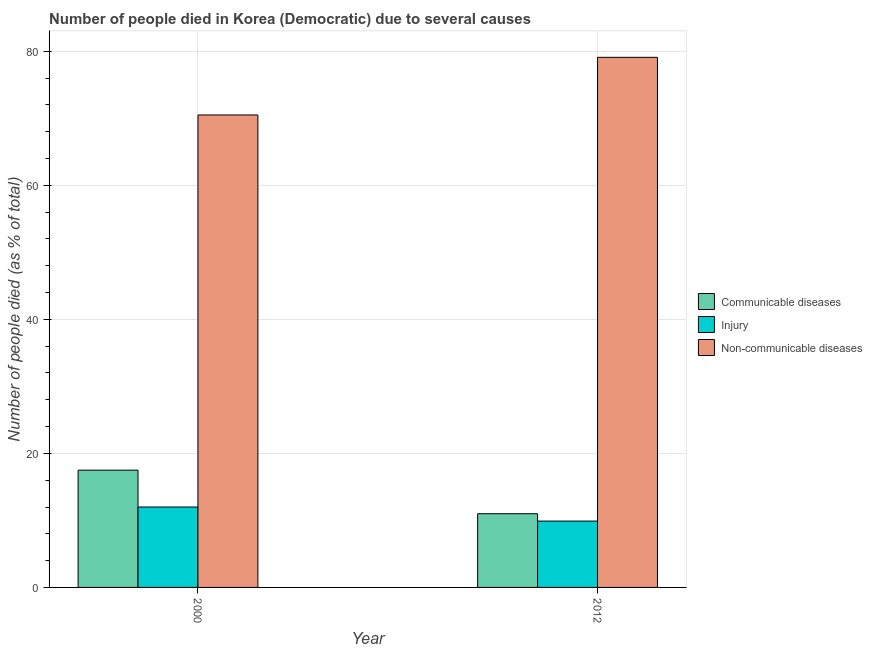How many different coloured bars are there?
Make the answer very short. 3. How many groups of bars are there?
Provide a succinct answer. 2. In how many cases, is the number of bars for a given year not equal to the number of legend labels?
Offer a very short reply. 0. What is the total number of people who died of communicable diseases in the graph?
Ensure brevity in your answer.  28.5. What is the difference between the number of people who dies of non-communicable diseases in 2000 and that in 2012?
Offer a terse response. -8.6. What is the difference between the number of people who died of communicable diseases in 2000 and the number of people who died of injury in 2012?
Provide a short and direct response. 6.5. What is the average number of people who died of communicable diseases per year?
Your response must be concise. 14.25. In how many years, is the number of people who died of communicable diseases greater than 56 %?
Provide a short and direct response. 0. What is the ratio of the number of people who died of communicable diseases in 2000 to that in 2012?
Ensure brevity in your answer.  1.59. In how many years, is the number of people who died of communicable diseases greater than the average number of people who died of communicable diseases taken over all years?
Make the answer very short. 1. What does the 1st bar from the left in 2012 represents?
Offer a very short reply. Communicable diseases. What does the 1st bar from the right in 2000 represents?
Provide a succinct answer. Non-communicable diseases. How many years are there in the graph?
Give a very brief answer. 2. What is the difference between two consecutive major ticks on the Y-axis?
Keep it short and to the point. 20. Are the values on the major ticks of Y-axis written in scientific E-notation?
Offer a terse response. No. Does the graph contain any zero values?
Offer a terse response. No. Where does the legend appear in the graph?
Offer a very short reply. Center right. How many legend labels are there?
Your answer should be very brief. 3. How are the legend labels stacked?
Provide a short and direct response. Vertical. What is the title of the graph?
Provide a succinct answer. Number of people died in Korea (Democratic) due to several causes. What is the label or title of the X-axis?
Your response must be concise. Year. What is the label or title of the Y-axis?
Your answer should be compact. Number of people died (as % of total). What is the Number of people died (as % of total) in Communicable diseases in 2000?
Make the answer very short. 17.5. What is the Number of people died (as % of total) in Non-communicable diseases in 2000?
Your response must be concise. 70.5. What is the Number of people died (as % of total) in Non-communicable diseases in 2012?
Offer a very short reply. 79.1. Across all years, what is the maximum Number of people died (as % of total) in Injury?
Your answer should be very brief. 12. Across all years, what is the maximum Number of people died (as % of total) in Non-communicable diseases?
Give a very brief answer. 79.1. Across all years, what is the minimum Number of people died (as % of total) in Communicable diseases?
Provide a short and direct response. 11. Across all years, what is the minimum Number of people died (as % of total) of Non-communicable diseases?
Offer a very short reply. 70.5. What is the total Number of people died (as % of total) in Communicable diseases in the graph?
Your answer should be compact. 28.5. What is the total Number of people died (as % of total) of Injury in the graph?
Keep it short and to the point. 21.9. What is the total Number of people died (as % of total) of Non-communicable diseases in the graph?
Make the answer very short. 149.6. What is the difference between the Number of people died (as % of total) of Communicable diseases in 2000 and the Number of people died (as % of total) of Injury in 2012?
Ensure brevity in your answer.  7.6. What is the difference between the Number of people died (as % of total) in Communicable diseases in 2000 and the Number of people died (as % of total) in Non-communicable diseases in 2012?
Keep it short and to the point. -61.6. What is the difference between the Number of people died (as % of total) of Injury in 2000 and the Number of people died (as % of total) of Non-communicable diseases in 2012?
Provide a short and direct response. -67.1. What is the average Number of people died (as % of total) in Communicable diseases per year?
Keep it short and to the point. 14.25. What is the average Number of people died (as % of total) of Injury per year?
Your answer should be compact. 10.95. What is the average Number of people died (as % of total) in Non-communicable diseases per year?
Your answer should be compact. 74.8. In the year 2000, what is the difference between the Number of people died (as % of total) in Communicable diseases and Number of people died (as % of total) in Injury?
Ensure brevity in your answer.  5.5. In the year 2000, what is the difference between the Number of people died (as % of total) in Communicable diseases and Number of people died (as % of total) in Non-communicable diseases?
Offer a terse response. -53. In the year 2000, what is the difference between the Number of people died (as % of total) of Injury and Number of people died (as % of total) of Non-communicable diseases?
Provide a short and direct response. -58.5. In the year 2012, what is the difference between the Number of people died (as % of total) in Communicable diseases and Number of people died (as % of total) in Non-communicable diseases?
Your response must be concise. -68.1. In the year 2012, what is the difference between the Number of people died (as % of total) in Injury and Number of people died (as % of total) in Non-communicable diseases?
Your answer should be compact. -69.2. What is the ratio of the Number of people died (as % of total) in Communicable diseases in 2000 to that in 2012?
Your response must be concise. 1.59. What is the ratio of the Number of people died (as % of total) in Injury in 2000 to that in 2012?
Ensure brevity in your answer.  1.21. What is the ratio of the Number of people died (as % of total) of Non-communicable diseases in 2000 to that in 2012?
Your response must be concise. 0.89. What is the difference between the highest and the second highest Number of people died (as % of total) in Communicable diseases?
Provide a short and direct response. 6.5. What is the difference between the highest and the second highest Number of people died (as % of total) in Injury?
Keep it short and to the point. 2.1. What is the difference between the highest and the lowest Number of people died (as % of total) in Communicable diseases?
Keep it short and to the point. 6.5. What is the difference between the highest and the lowest Number of people died (as % of total) in Non-communicable diseases?
Your answer should be compact. 8.6. 